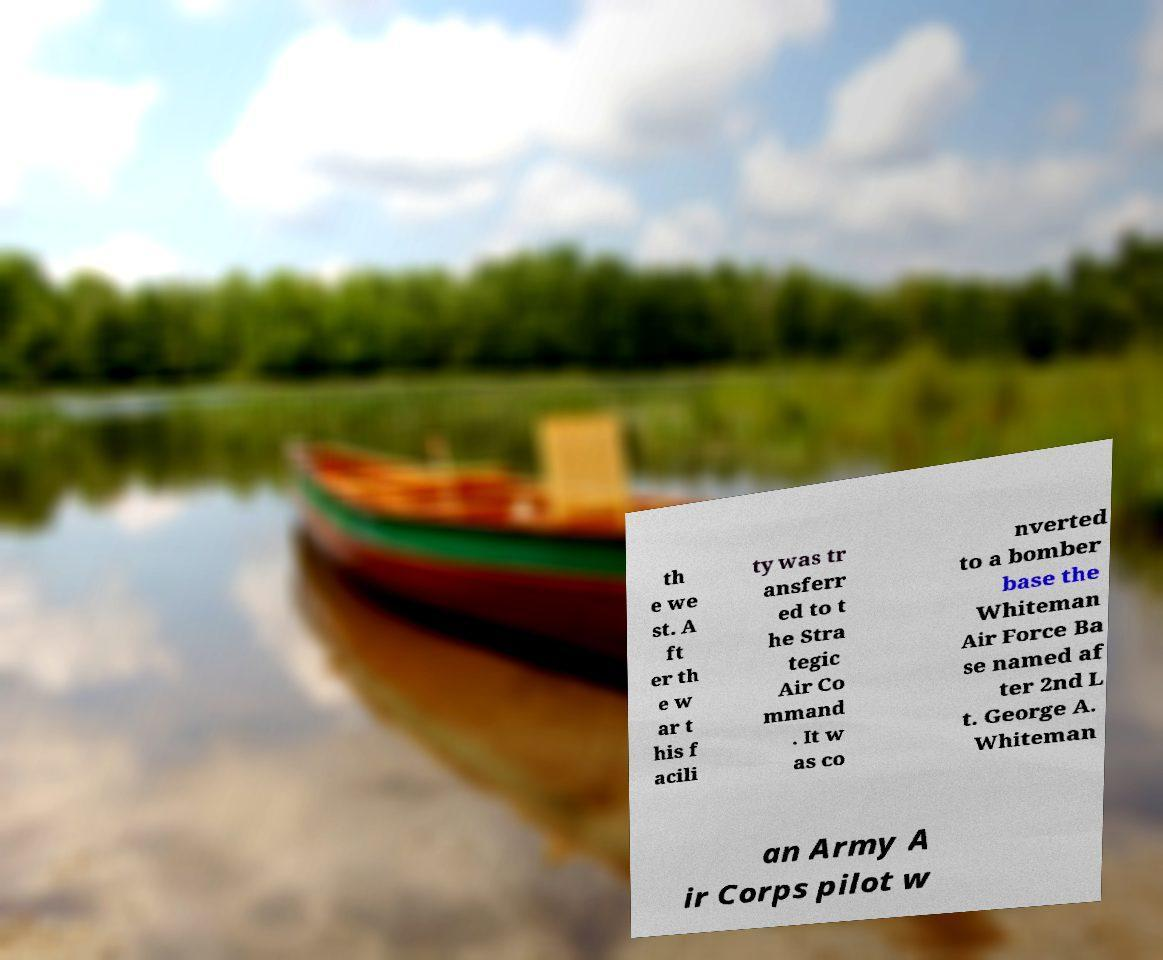There's text embedded in this image that I need extracted. Can you transcribe it verbatim? th e we st. A ft er th e w ar t his f acili ty was tr ansferr ed to t he Stra tegic Air Co mmand . It w as co nverted to a bomber base the Whiteman Air Force Ba se named af ter 2nd L t. George A. Whiteman an Army A ir Corps pilot w 